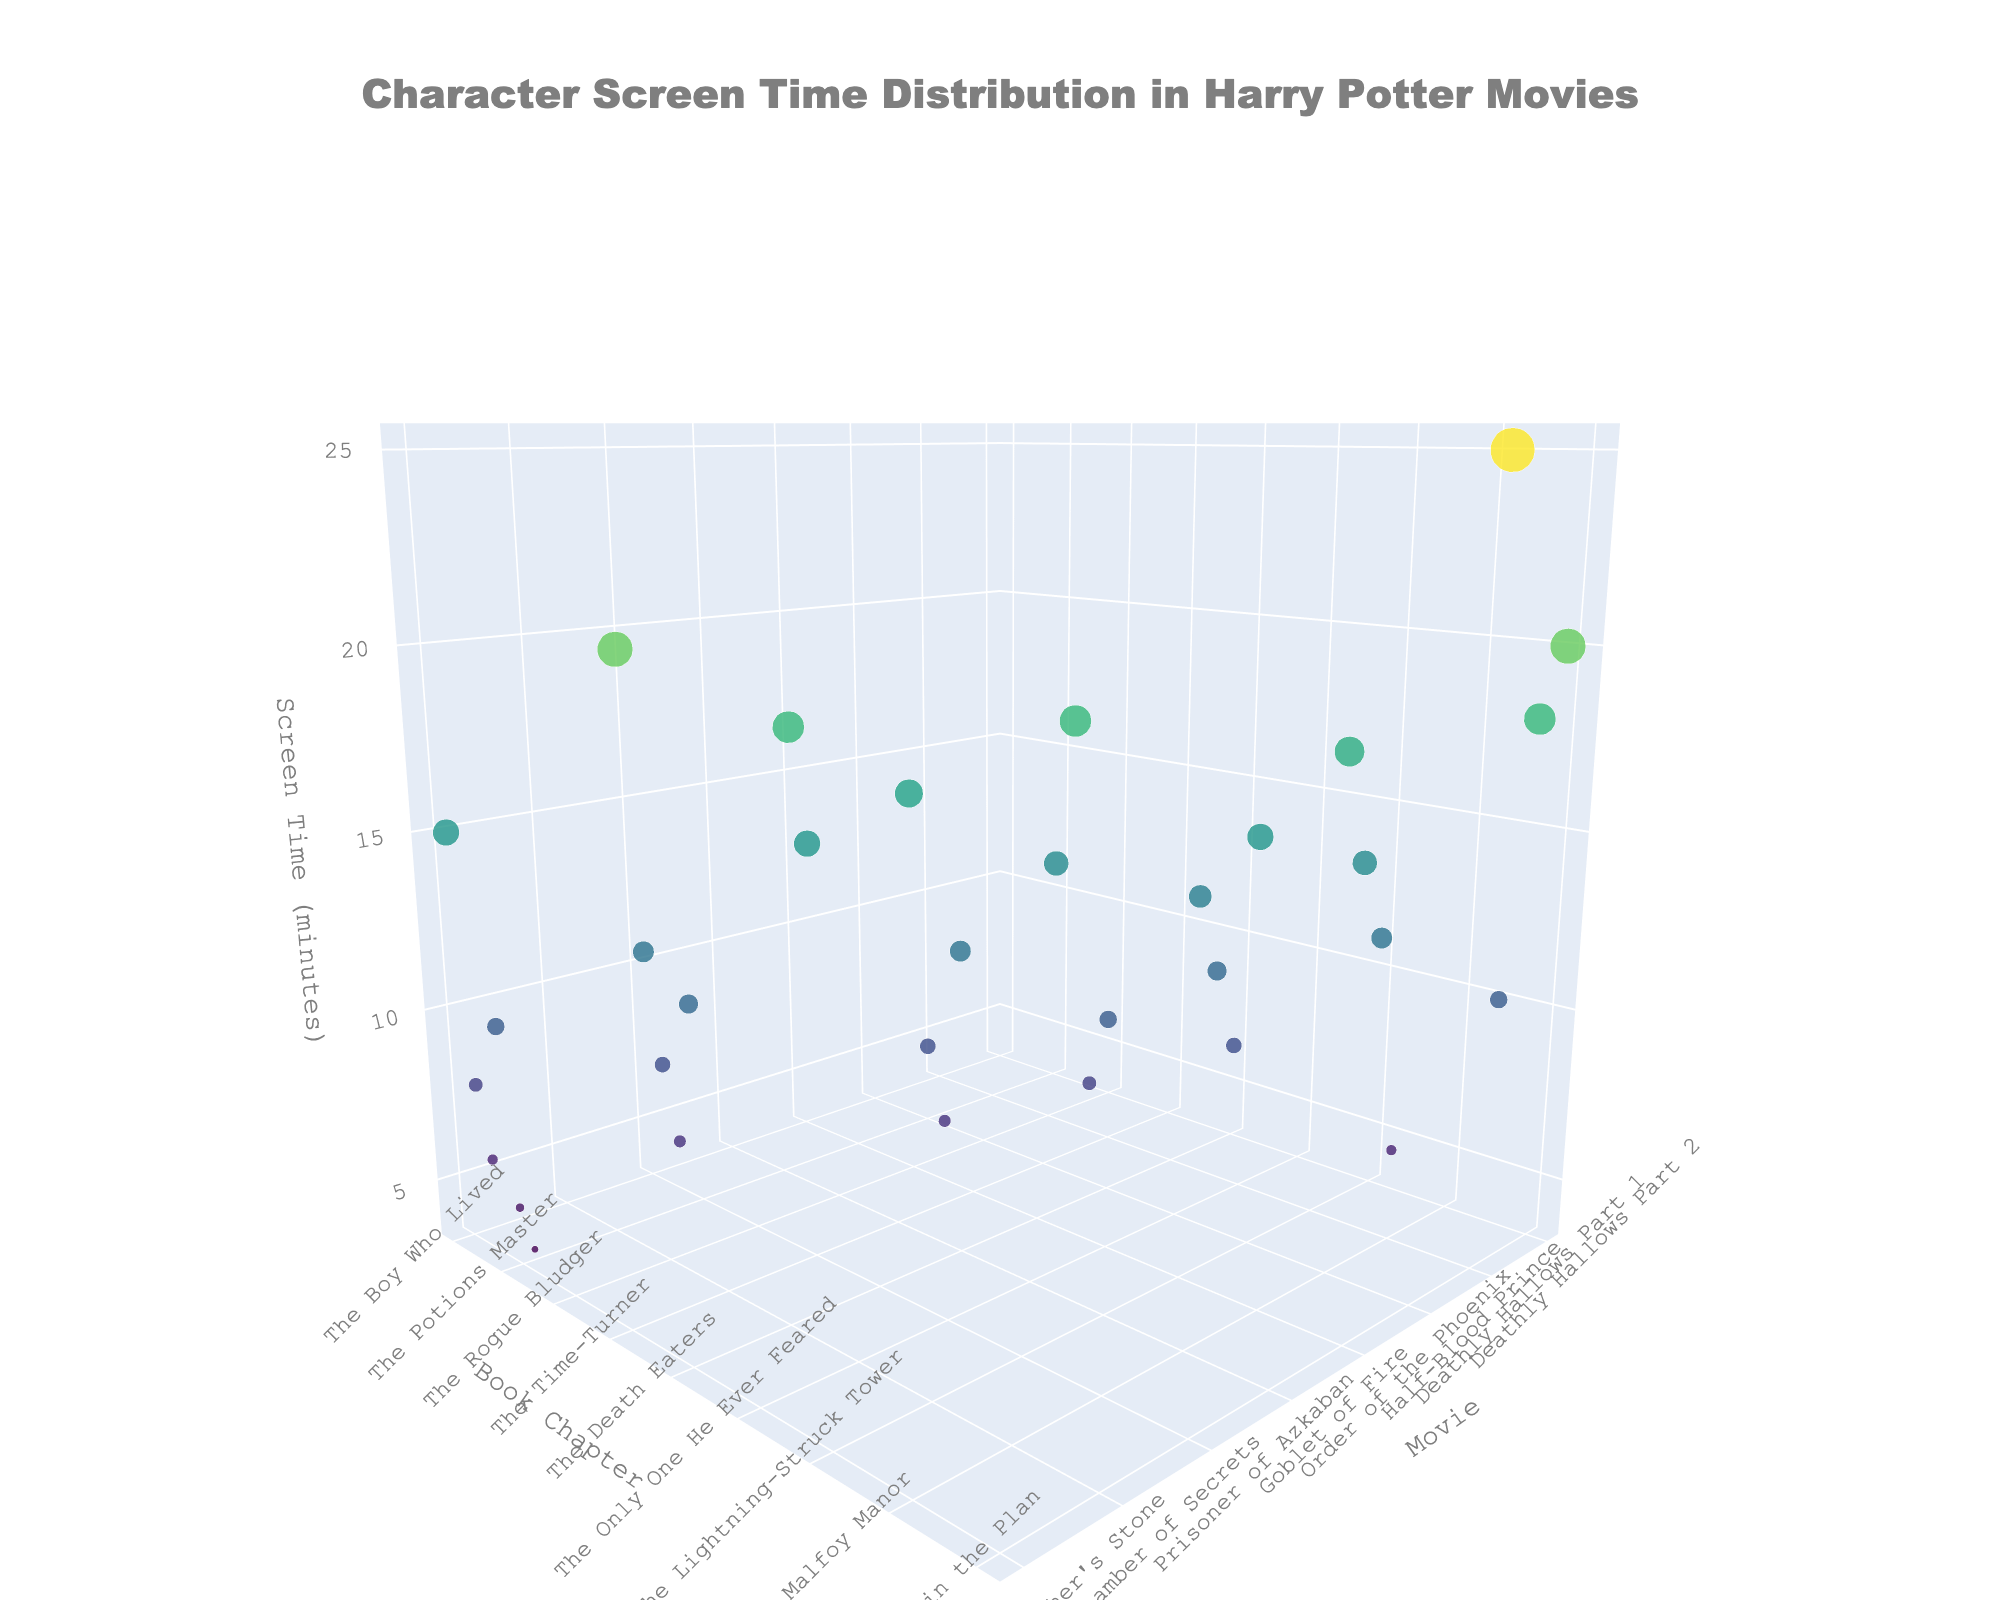What is the title of the plot? The title is prominently displayed at the top of the plot. From the provided explanation, it is "Character Screen Time Distribution in Harry Potter Movies."
Answer: Character Screen Time Distribution in Harry Potter Movies Which character has the highest screen time in "The Battle of Hogwarts" chapter in “Deathly Hallows Part 2”? By examining the data points related to "The Battle of Hogwarts" chapter in "Deathly Hallows Part 2," you can identify that Harry Potter has the highest screen time.
Answer: Harry Potter How do the screen times of Harry Potter compare between "The Philosopher's Stone" and "Order of the Phoenix"? To compare screen times, find the values for Harry Potter in both "The Philosopher's Stone" and "Order of the Phoenix." Harry has 15 minutes in "The Philosopher's Stone" and 14 minutes in "Order of the Phoenix."
Answer: 15 minutes in The Philosopher's Stone, 14 minutes in Order of the Phoenix What is the average screen time of Harry Potter across all movies? Add up all screen times of Harry Potter across the movies and divide by the number of instances: (15 + 20 + 18 + 16 + 14 + 13 + 17 + 25) / 8 = 138 / 8 = 17.25
Answer: 17.25 minutes Which movie features the character Voldemort with the most screen time? Check Voldemort's screen times across different movies. Voldemort appears with the highest screen time of 20 minutes in "Deathly Hallows Part 2."
Answer: Deathly Hallows Part 2 Compare the screen time of Severus Snape in "Philosopher's Stone" and "Deathly Hallows Part 2." Severus Snape has 5 minutes in "Philosopher's Stone" and 18 minutes in "Deathly Hallows Part 2," showing an increase.
Answer: 5 minutes in Philosopher's Stone, 18 minutes in Deathly Hallows Part 2 What is the total screen time for Hermione Granger in "Philosopher's Stone," "Chamber of Secrets," and "Prisoner of Azkaban"? Add her screen times in the respective movies: 8 (Philosopher's Stone) + 12 (Chamber of Secrets) + 15 (Prisoner of Azkaban) = 35 minutes total.
Answer: 35 minutes Identify which character has the most screen time in "Order of the Phoenix." Reviewing screen times for characters in "Order of the Phoenix," Dolores Umbridge has the highest with 18 minutes.
Answer: Dolores Umbridge Does Draco Malfoy appear more in "Philosopher's Stone" or "Half-Blood Prince"? Draco Malfoy has 4 minutes in "Philosopher's Stone" and 9 minutes in "Half-Blood Prince." Clearly, he appears more in "Half-Blood Prince."
Answer: Half-Blood Prince 